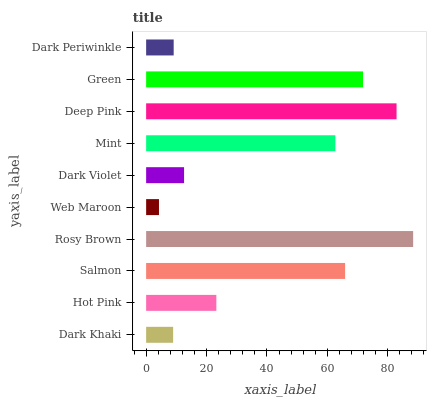Is Web Maroon the minimum?
Answer yes or no. Yes. Is Rosy Brown the maximum?
Answer yes or no. Yes. Is Hot Pink the minimum?
Answer yes or no. No. Is Hot Pink the maximum?
Answer yes or no. No. Is Hot Pink greater than Dark Khaki?
Answer yes or no. Yes. Is Dark Khaki less than Hot Pink?
Answer yes or no. Yes. Is Dark Khaki greater than Hot Pink?
Answer yes or no. No. Is Hot Pink less than Dark Khaki?
Answer yes or no. No. Is Mint the high median?
Answer yes or no. Yes. Is Hot Pink the low median?
Answer yes or no. Yes. Is Green the high median?
Answer yes or no. No. Is Dark Khaki the low median?
Answer yes or no. No. 